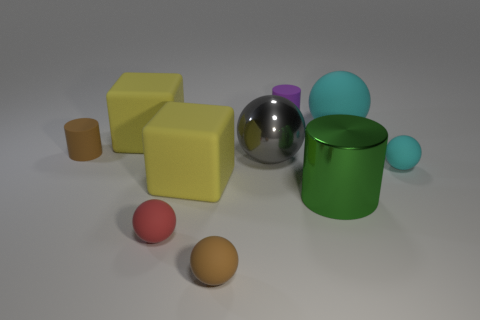There is a tiny cylinder on the left side of the large gray ball; does it have the same color as the small matte sphere to the right of the gray thing?
Your response must be concise. No. What is the material of the green cylinder that is the same size as the gray thing?
Keep it short and to the point. Metal. There is a brown thing right of the brown rubber thing behind the tiny brown object that is in front of the green metallic cylinder; how big is it?
Offer a terse response. Small. What number of other objects are there of the same material as the large cyan object?
Your answer should be very brief. 7. How big is the brown thing in front of the green metallic object?
Your response must be concise. Small. How many matte balls are in front of the big cyan ball and behind the red rubber object?
Your response must be concise. 1. There is a small brown object that is behind the brown thing that is in front of the small brown cylinder; what is it made of?
Your answer should be compact. Rubber. There is a purple object that is the same shape as the green metal object; what is it made of?
Offer a terse response. Rubber. Are any small red rubber blocks visible?
Keep it short and to the point. No. The purple object that is made of the same material as the tiny red sphere is what shape?
Your answer should be compact. Cylinder. 